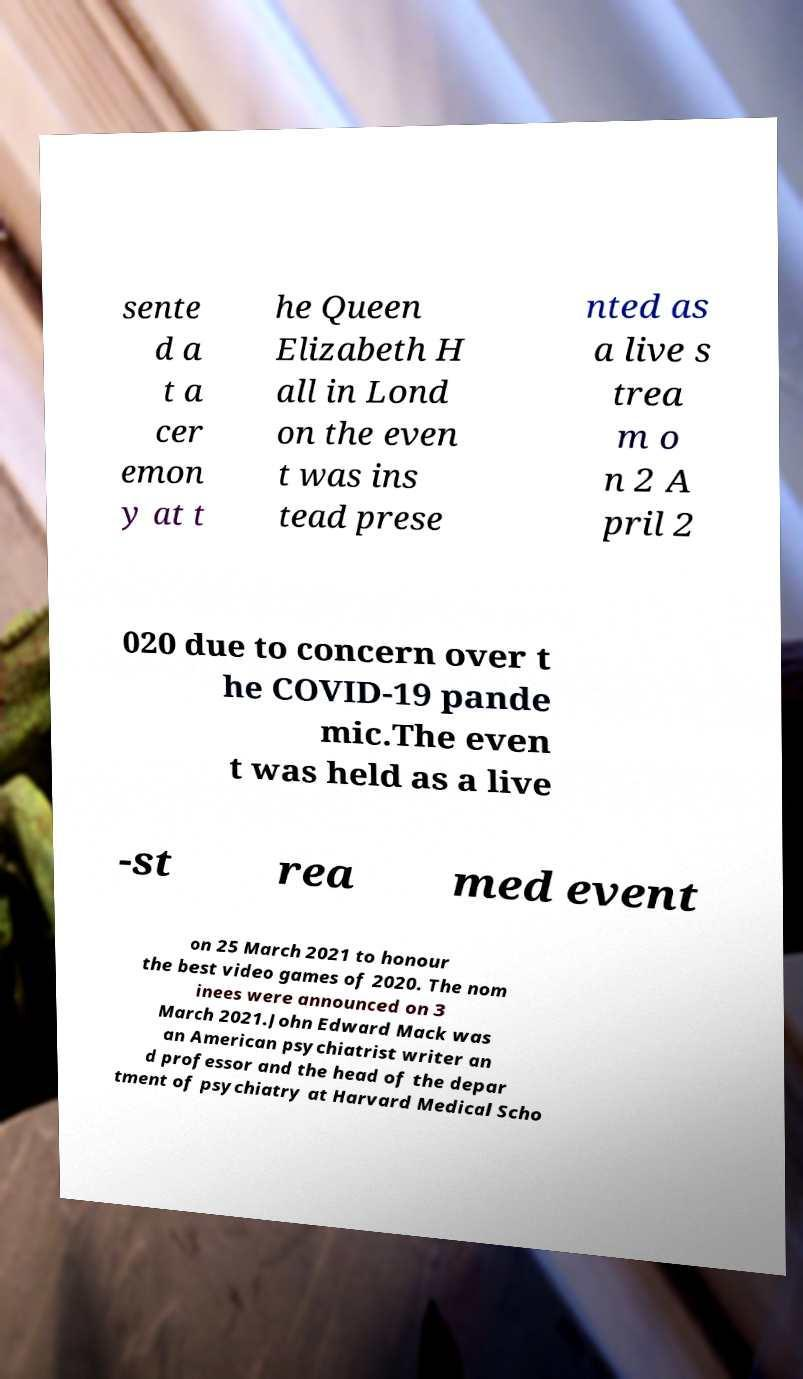I need the written content from this picture converted into text. Can you do that? sente d a t a cer emon y at t he Queen Elizabeth H all in Lond on the even t was ins tead prese nted as a live s trea m o n 2 A pril 2 020 due to concern over t he COVID-19 pande mic.The even t was held as a live -st rea med event on 25 March 2021 to honour the best video games of 2020. The nom inees were announced on 3 March 2021.John Edward Mack was an American psychiatrist writer an d professor and the head of the depar tment of psychiatry at Harvard Medical Scho 